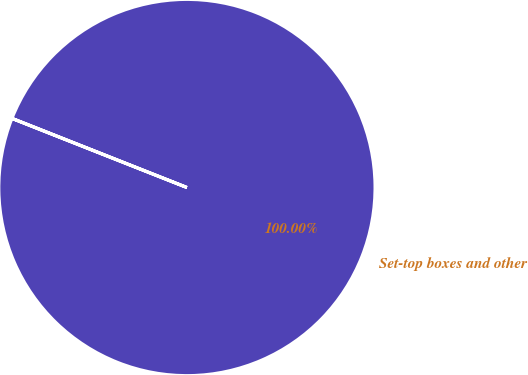<chart> <loc_0><loc_0><loc_500><loc_500><pie_chart><fcel>Set-top boxes and other<nl><fcel>100.0%<nl></chart> 